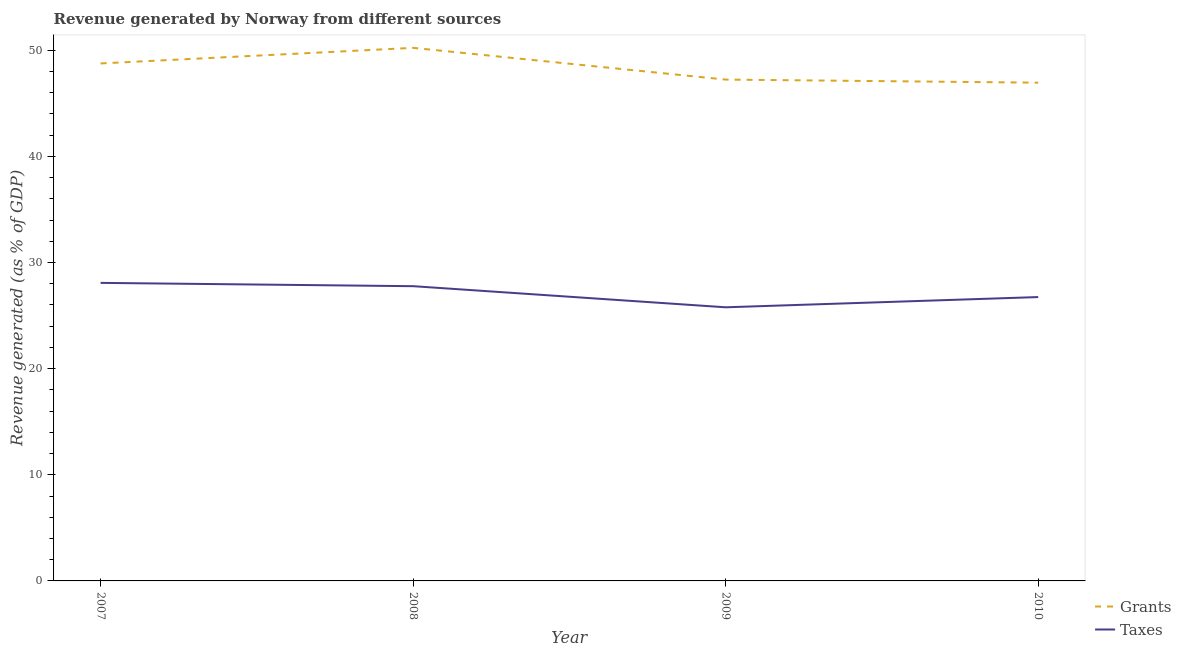How many different coloured lines are there?
Make the answer very short. 2. What is the revenue generated by grants in 2007?
Your response must be concise. 48.76. Across all years, what is the maximum revenue generated by grants?
Your response must be concise. 50.23. Across all years, what is the minimum revenue generated by grants?
Your answer should be very brief. 46.94. In which year was the revenue generated by taxes minimum?
Provide a short and direct response. 2009. What is the total revenue generated by grants in the graph?
Offer a terse response. 193.16. What is the difference between the revenue generated by taxes in 2007 and that in 2010?
Your answer should be very brief. 1.34. What is the difference between the revenue generated by taxes in 2008 and the revenue generated by grants in 2009?
Your answer should be compact. -19.46. What is the average revenue generated by grants per year?
Your response must be concise. 48.29. In the year 2007, what is the difference between the revenue generated by grants and revenue generated by taxes?
Your answer should be very brief. 20.67. What is the ratio of the revenue generated by taxes in 2007 to that in 2008?
Ensure brevity in your answer.  1.01. Is the revenue generated by taxes in 2007 less than that in 2008?
Your response must be concise. No. Is the difference between the revenue generated by grants in 2009 and 2010 greater than the difference between the revenue generated by taxes in 2009 and 2010?
Your response must be concise. Yes. What is the difference between the highest and the second highest revenue generated by grants?
Provide a succinct answer. 1.47. What is the difference between the highest and the lowest revenue generated by grants?
Make the answer very short. 3.28. In how many years, is the revenue generated by taxes greater than the average revenue generated by taxes taken over all years?
Offer a very short reply. 2. Is the sum of the revenue generated by taxes in 2007 and 2010 greater than the maximum revenue generated by grants across all years?
Your response must be concise. Yes. Is the revenue generated by taxes strictly less than the revenue generated by grants over the years?
Make the answer very short. Yes. How many lines are there?
Make the answer very short. 2. How many years are there in the graph?
Offer a terse response. 4. Are the values on the major ticks of Y-axis written in scientific E-notation?
Your answer should be very brief. No. Does the graph contain grids?
Keep it short and to the point. No. Where does the legend appear in the graph?
Offer a terse response. Bottom right. How many legend labels are there?
Your answer should be compact. 2. What is the title of the graph?
Your response must be concise. Revenue generated by Norway from different sources. Does "Foreign Liabilities" appear as one of the legend labels in the graph?
Your answer should be compact. No. What is the label or title of the X-axis?
Your response must be concise. Year. What is the label or title of the Y-axis?
Offer a terse response. Revenue generated (as % of GDP). What is the Revenue generated (as % of GDP) in Grants in 2007?
Provide a short and direct response. 48.76. What is the Revenue generated (as % of GDP) of Taxes in 2007?
Your answer should be very brief. 28.08. What is the Revenue generated (as % of GDP) of Grants in 2008?
Ensure brevity in your answer.  50.23. What is the Revenue generated (as % of GDP) in Taxes in 2008?
Your answer should be compact. 27.77. What is the Revenue generated (as % of GDP) in Grants in 2009?
Keep it short and to the point. 47.23. What is the Revenue generated (as % of GDP) in Taxes in 2009?
Your response must be concise. 25.78. What is the Revenue generated (as % of GDP) in Grants in 2010?
Offer a very short reply. 46.94. What is the Revenue generated (as % of GDP) in Taxes in 2010?
Offer a terse response. 26.74. Across all years, what is the maximum Revenue generated (as % of GDP) of Grants?
Keep it short and to the point. 50.23. Across all years, what is the maximum Revenue generated (as % of GDP) of Taxes?
Keep it short and to the point. 28.08. Across all years, what is the minimum Revenue generated (as % of GDP) of Grants?
Offer a very short reply. 46.94. Across all years, what is the minimum Revenue generated (as % of GDP) of Taxes?
Provide a succinct answer. 25.78. What is the total Revenue generated (as % of GDP) of Grants in the graph?
Your response must be concise. 193.16. What is the total Revenue generated (as % of GDP) in Taxes in the graph?
Make the answer very short. 108.38. What is the difference between the Revenue generated (as % of GDP) of Grants in 2007 and that in 2008?
Provide a succinct answer. -1.47. What is the difference between the Revenue generated (as % of GDP) of Taxes in 2007 and that in 2008?
Offer a very short reply. 0.31. What is the difference between the Revenue generated (as % of GDP) in Grants in 2007 and that in 2009?
Your response must be concise. 1.52. What is the difference between the Revenue generated (as % of GDP) of Taxes in 2007 and that in 2009?
Your response must be concise. 2.3. What is the difference between the Revenue generated (as % of GDP) of Grants in 2007 and that in 2010?
Give a very brief answer. 1.81. What is the difference between the Revenue generated (as % of GDP) of Taxes in 2007 and that in 2010?
Provide a succinct answer. 1.34. What is the difference between the Revenue generated (as % of GDP) of Grants in 2008 and that in 2009?
Provide a succinct answer. 2.99. What is the difference between the Revenue generated (as % of GDP) in Taxes in 2008 and that in 2009?
Your answer should be compact. 1.99. What is the difference between the Revenue generated (as % of GDP) of Grants in 2008 and that in 2010?
Your answer should be very brief. 3.28. What is the difference between the Revenue generated (as % of GDP) in Taxes in 2008 and that in 2010?
Provide a succinct answer. 1.03. What is the difference between the Revenue generated (as % of GDP) in Grants in 2009 and that in 2010?
Your answer should be very brief. 0.29. What is the difference between the Revenue generated (as % of GDP) of Taxes in 2009 and that in 2010?
Give a very brief answer. -0.96. What is the difference between the Revenue generated (as % of GDP) in Grants in 2007 and the Revenue generated (as % of GDP) in Taxes in 2008?
Keep it short and to the point. 20.99. What is the difference between the Revenue generated (as % of GDP) in Grants in 2007 and the Revenue generated (as % of GDP) in Taxes in 2009?
Your answer should be compact. 22.98. What is the difference between the Revenue generated (as % of GDP) of Grants in 2007 and the Revenue generated (as % of GDP) of Taxes in 2010?
Make the answer very short. 22.01. What is the difference between the Revenue generated (as % of GDP) of Grants in 2008 and the Revenue generated (as % of GDP) of Taxes in 2009?
Make the answer very short. 24.44. What is the difference between the Revenue generated (as % of GDP) in Grants in 2008 and the Revenue generated (as % of GDP) in Taxes in 2010?
Offer a very short reply. 23.48. What is the difference between the Revenue generated (as % of GDP) in Grants in 2009 and the Revenue generated (as % of GDP) in Taxes in 2010?
Keep it short and to the point. 20.49. What is the average Revenue generated (as % of GDP) in Grants per year?
Keep it short and to the point. 48.29. What is the average Revenue generated (as % of GDP) in Taxes per year?
Your answer should be compact. 27.09. In the year 2007, what is the difference between the Revenue generated (as % of GDP) of Grants and Revenue generated (as % of GDP) of Taxes?
Your answer should be very brief. 20.67. In the year 2008, what is the difference between the Revenue generated (as % of GDP) of Grants and Revenue generated (as % of GDP) of Taxes?
Your answer should be compact. 22.46. In the year 2009, what is the difference between the Revenue generated (as % of GDP) of Grants and Revenue generated (as % of GDP) of Taxes?
Your response must be concise. 21.45. In the year 2010, what is the difference between the Revenue generated (as % of GDP) in Grants and Revenue generated (as % of GDP) in Taxes?
Your response must be concise. 20.2. What is the ratio of the Revenue generated (as % of GDP) in Grants in 2007 to that in 2008?
Provide a short and direct response. 0.97. What is the ratio of the Revenue generated (as % of GDP) of Taxes in 2007 to that in 2008?
Provide a short and direct response. 1.01. What is the ratio of the Revenue generated (as % of GDP) of Grants in 2007 to that in 2009?
Offer a terse response. 1.03. What is the ratio of the Revenue generated (as % of GDP) of Taxes in 2007 to that in 2009?
Your response must be concise. 1.09. What is the ratio of the Revenue generated (as % of GDP) in Grants in 2007 to that in 2010?
Keep it short and to the point. 1.04. What is the ratio of the Revenue generated (as % of GDP) in Taxes in 2007 to that in 2010?
Give a very brief answer. 1.05. What is the ratio of the Revenue generated (as % of GDP) in Grants in 2008 to that in 2009?
Provide a succinct answer. 1.06. What is the ratio of the Revenue generated (as % of GDP) of Taxes in 2008 to that in 2009?
Keep it short and to the point. 1.08. What is the ratio of the Revenue generated (as % of GDP) in Grants in 2008 to that in 2010?
Offer a terse response. 1.07. What is the ratio of the Revenue generated (as % of GDP) in Taxes in 2008 to that in 2010?
Offer a terse response. 1.04. What is the ratio of the Revenue generated (as % of GDP) in Taxes in 2009 to that in 2010?
Make the answer very short. 0.96. What is the difference between the highest and the second highest Revenue generated (as % of GDP) in Grants?
Make the answer very short. 1.47. What is the difference between the highest and the second highest Revenue generated (as % of GDP) in Taxes?
Ensure brevity in your answer.  0.31. What is the difference between the highest and the lowest Revenue generated (as % of GDP) in Grants?
Your response must be concise. 3.28. What is the difference between the highest and the lowest Revenue generated (as % of GDP) of Taxes?
Provide a succinct answer. 2.3. 